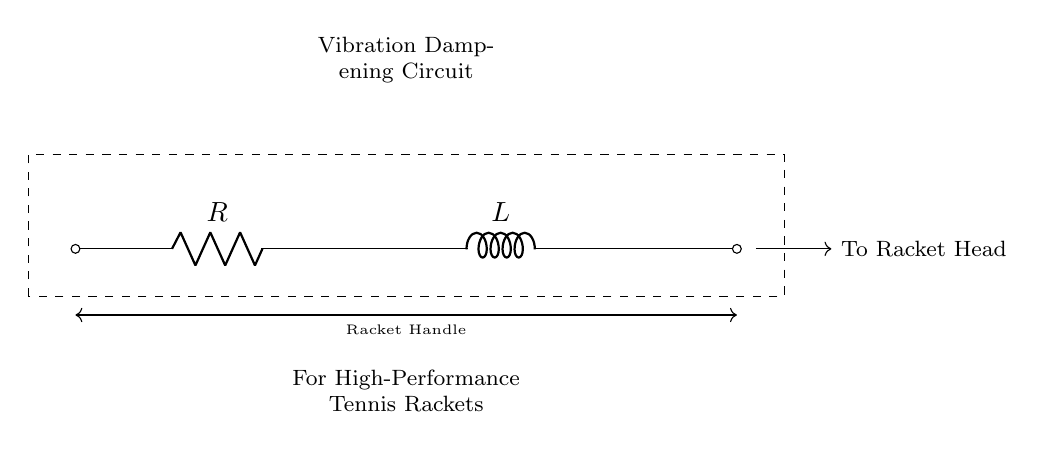What are the components of this circuit? The circuit consists of a resistor and an inductor, which are represented by R and L in the diagram.
Answer: Resistor and Inductor What is the purpose of this circuit? The circuit is designed for vibration dampening in high-performance tennis rackets, as indicated by the labeling in the diagram.
Answer: Vibration Dampening Where does the circuit connect in the racket? The dashed line represents the connection from the racket handle to the racket head, indicating where the circuit is implemented in the overall structure of the racket.
Answer: Racket Handle to Racket Head What type of circuit is represented here? This is an R-L series circuit, where a resistor (R) and an inductor (L) are connected in series with the output intended to reduce vibrations in the racket.
Answer: R-L Series Circuit How does the inductor affect the circuit's response to vibrations? The inductor temporarily stores energy in a magnetic field, which can help to smooth out changes in current and hence dampen vibrations, improving the racket's performance by reducing unwanted oscillations.
Answer: Dampening Vibrations How would you visualize the energy storage capacity of this circuit? The inductor in the circuit represents energy storage, and its value affects the amount of energy stored; thus, higher inductance leads to increased energy storage capacity.
Answer: Energy Storage What happens to the current if the resistance is increased? Increasing the resistance in this circuit would lead to a decrease in the overall current flow according to Ohm's Law (V=IR), affecting the vibration dampening effectiveness.
Answer: Decreased Current 